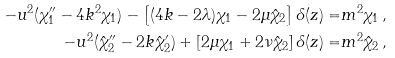<formula> <loc_0><loc_0><loc_500><loc_500>- u ^ { 2 } ( \chi _ { 1 } ^ { \prime \prime } - 4 k ^ { 2 } \chi _ { 1 } ) - \left [ ( 4 k - 2 \lambda ) \chi _ { 1 } - 2 \mu \hat { \chi } _ { 2 } \right ] \delta ( z ) = & m ^ { 2 } \chi _ { 1 } \, , \\ - u ^ { 2 } ( \hat { \chi } _ { 2 } ^ { \prime \prime } - 2 k \hat { \chi } _ { 2 } ^ { \prime } ) + \left [ 2 \mu \chi _ { 1 } + 2 \nu \hat { \chi } _ { 2 } \right ] \delta ( z ) = & m ^ { 2 } \hat { \chi } _ { 2 } \, ,</formula> 